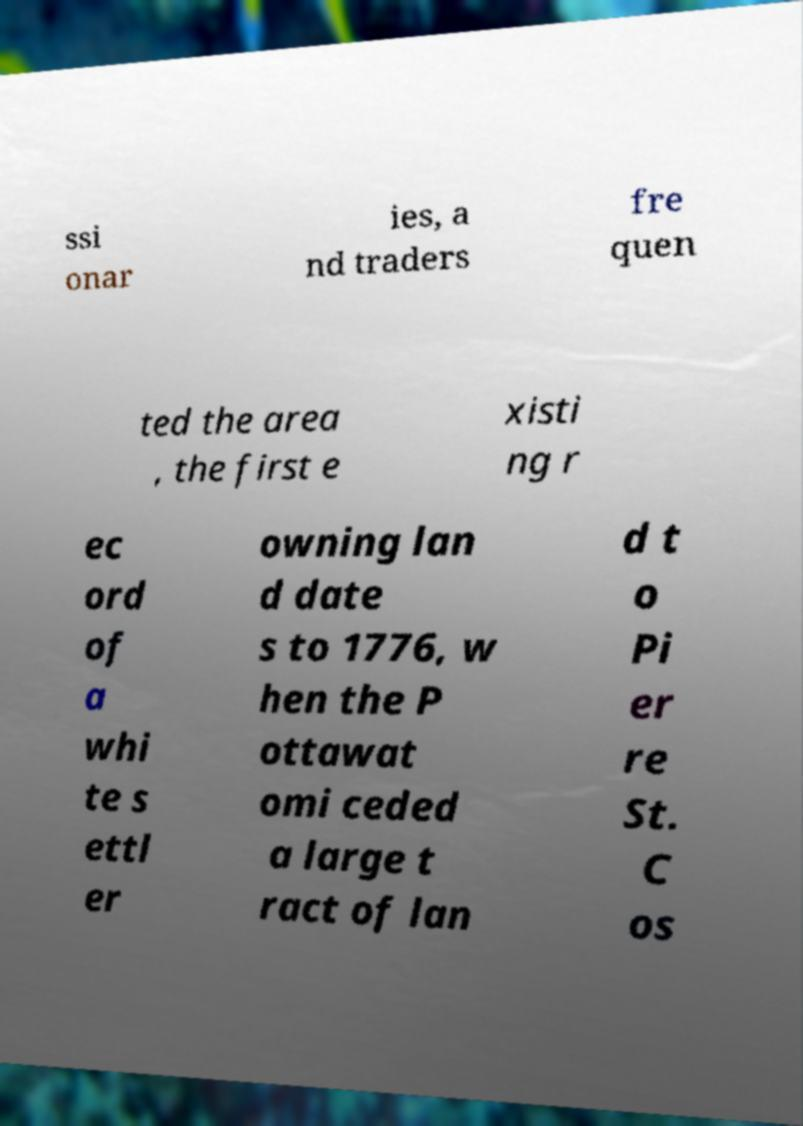I need the written content from this picture converted into text. Can you do that? ssi onar ies, a nd traders fre quen ted the area , the first e xisti ng r ec ord of a whi te s ettl er owning lan d date s to 1776, w hen the P ottawat omi ceded a large t ract of lan d t o Pi er re St. C os 